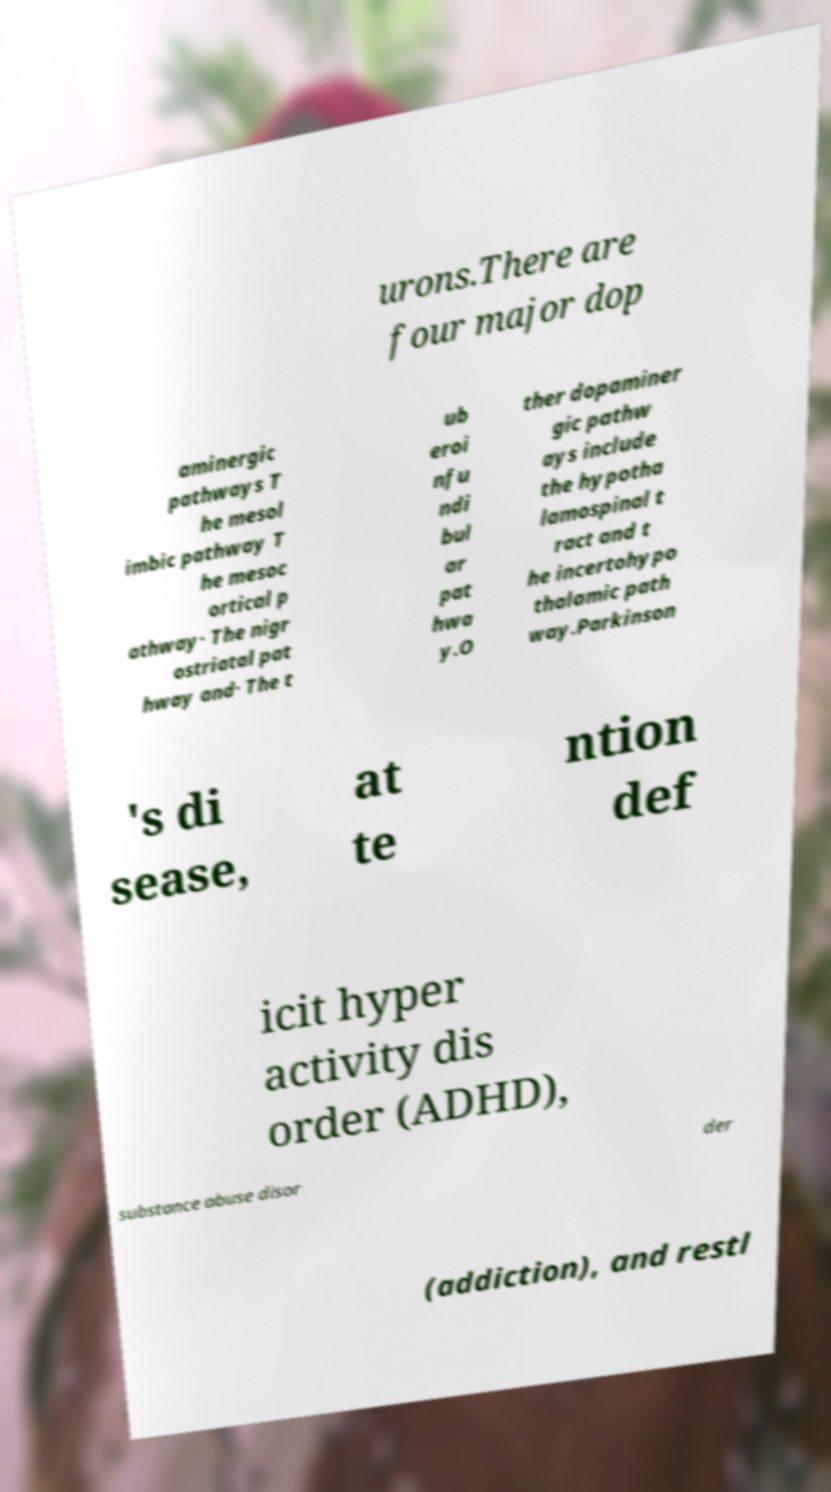Could you extract and type out the text from this image? urons.There are four major dop aminergic pathways T he mesol imbic pathway T he mesoc ortical p athway· The nigr ostriatal pat hway and· The t ub eroi nfu ndi bul ar pat hwa y.O ther dopaminer gic pathw ays include the hypotha lamospinal t ract and t he incertohypo thalamic path way.Parkinson 's di sease, at te ntion def icit hyper activity dis order (ADHD), substance abuse disor der (addiction), and restl 